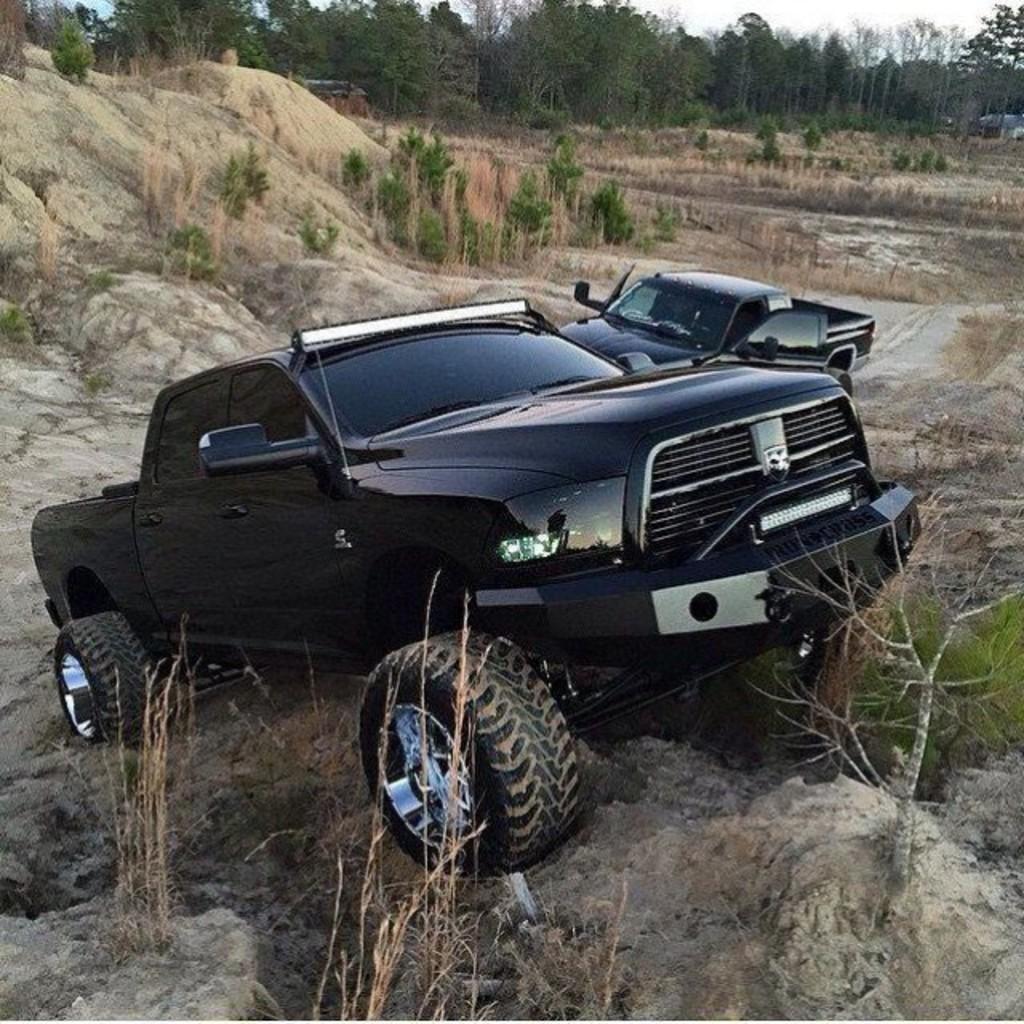Describe this image in one or two sentences. In this image there are cars on a hill area, in the background there are plants and trees. 